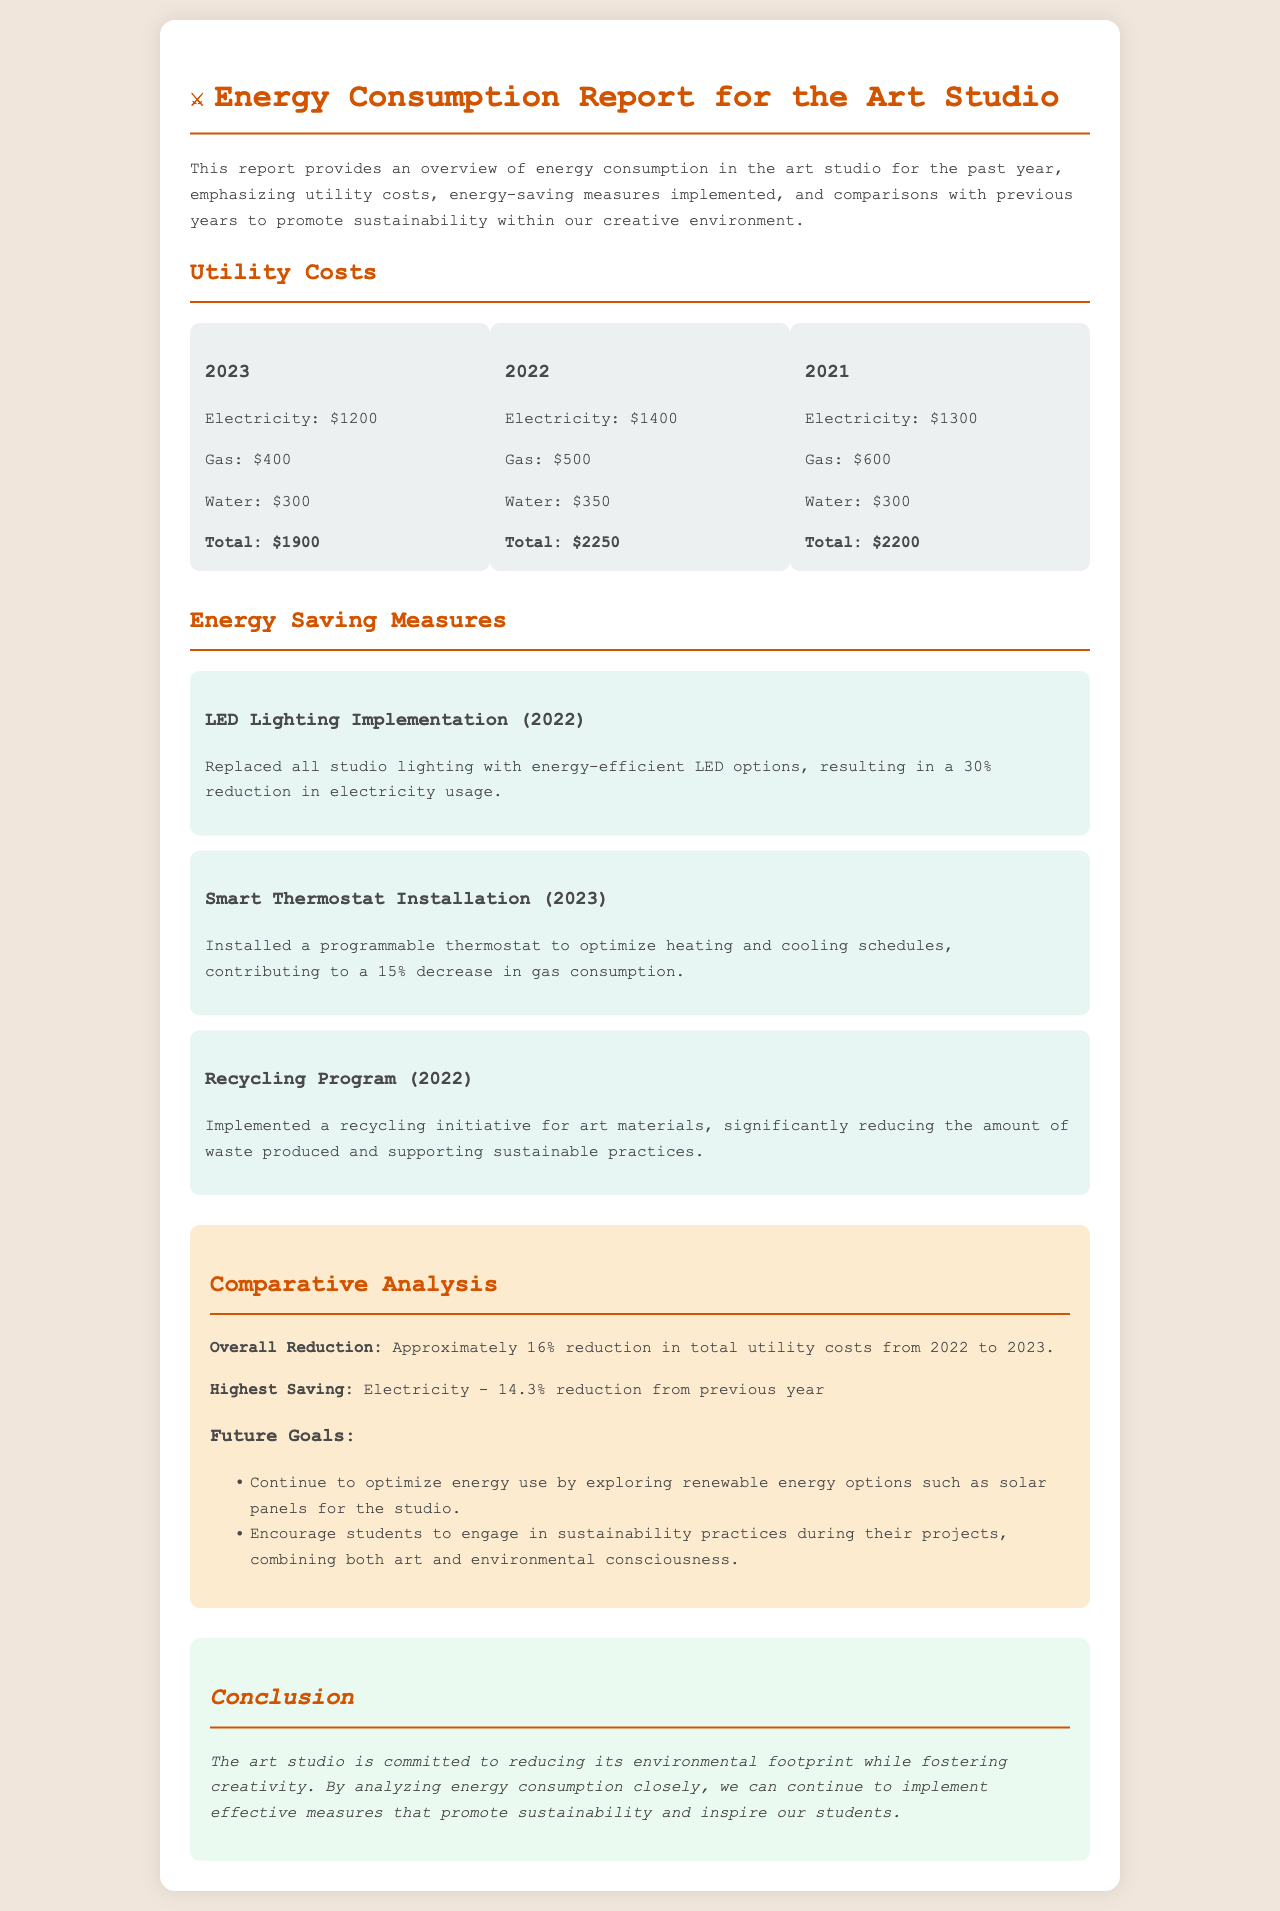What was the total utility cost in 2023? The total utility cost for 2023 is found in the utility costs section of the report, which lists $1900.
Answer: $1900 What energy-saving measure was implemented in 2023? The report mentions the installation of a smart thermostat as an energy-saving measure in 2023.
Answer: Smart Thermostat Installation By what percentage did electricity usage decrease from 2022 to 2023? The document specifies a reduction in electricity usage of 14.3% from the previous year, which is stated in the comparative analysis.
Answer: 14.3% What was the total utility cost for 2022? The total utility cost for 2022 can be found in the utility costs section of the report, which amounts to $2250.
Answer: $2250 What is the highest saving category mentioned in the report? The report highlights that the highest saving category is electricity, according to the comparative analysis section.
Answer: Electricity What type of recycling initiative was implemented? The report describes a recycling program for art materials as part of the energy-saving measures introduced in 2022.
Answer: Recycling Program What is one future goal mentioned in the document? The document outlines the goal of exploring renewable energy options such as solar panels for the studio as a future objective.
Answer: Solar panels What was the total utility cost for 2021? The total utility cost for 2021 is indicated in the utility costs section of the report, which lists $2200.
Answer: $2200 